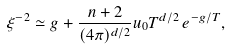Convert formula to latex. <formula><loc_0><loc_0><loc_500><loc_500>\xi ^ { - 2 } \simeq g + \frac { n + 2 } { ( 4 \pi ) ^ { d / 2 } } u _ { 0 } T ^ { d / 2 } \, e ^ { - g / T } ,</formula> 